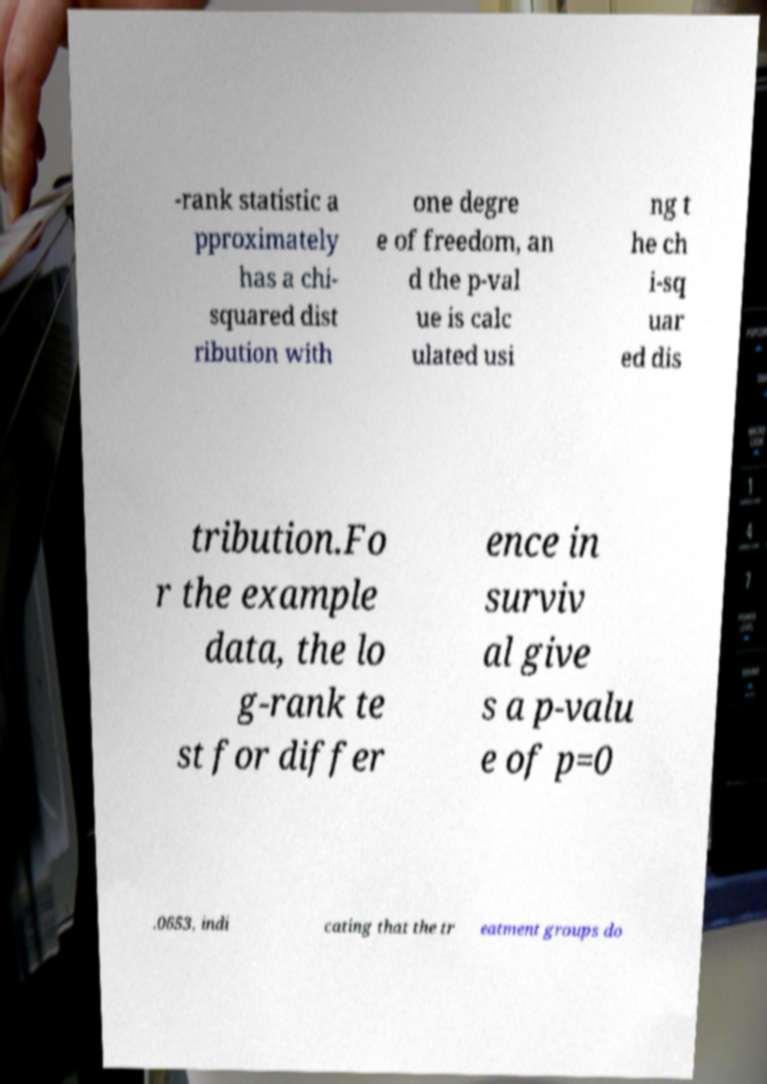Please read and relay the text visible in this image. What does it say? -rank statistic a pproximately has a chi- squared dist ribution with one degre e of freedom, an d the p-val ue is calc ulated usi ng t he ch i-sq uar ed dis tribution.Fo r the example data, the lo g-rank te st for differ ence in surviv al give s a p-valu e of p=0 .0653, indi cating that the tr eatment groups do 